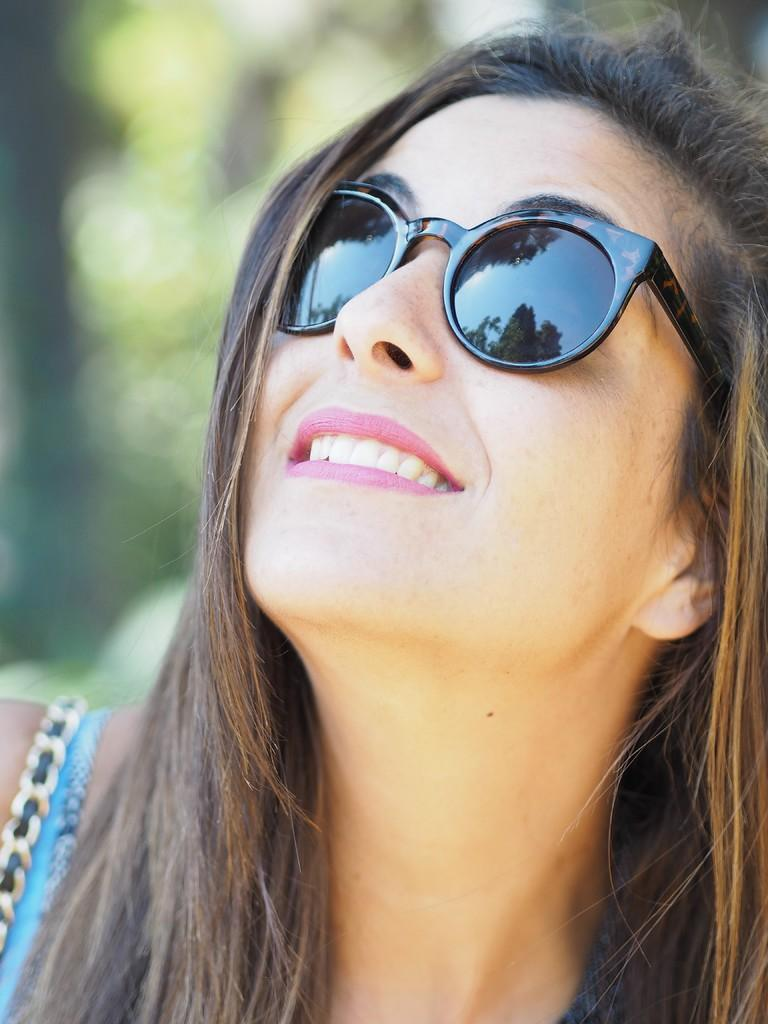Who is present in the image? There is a woman in the picture. What is the woman wearing on her face? The woman is wearing goggles. What is the woman's facial expression? The woman is smiling. What color is the background of the image? The background of the image is green. Can you tell me how many boats are docked in the harbor behind the woman? There is no harbor or boats present in the image; it features a woman wearing goggles and smiling against a green background. 